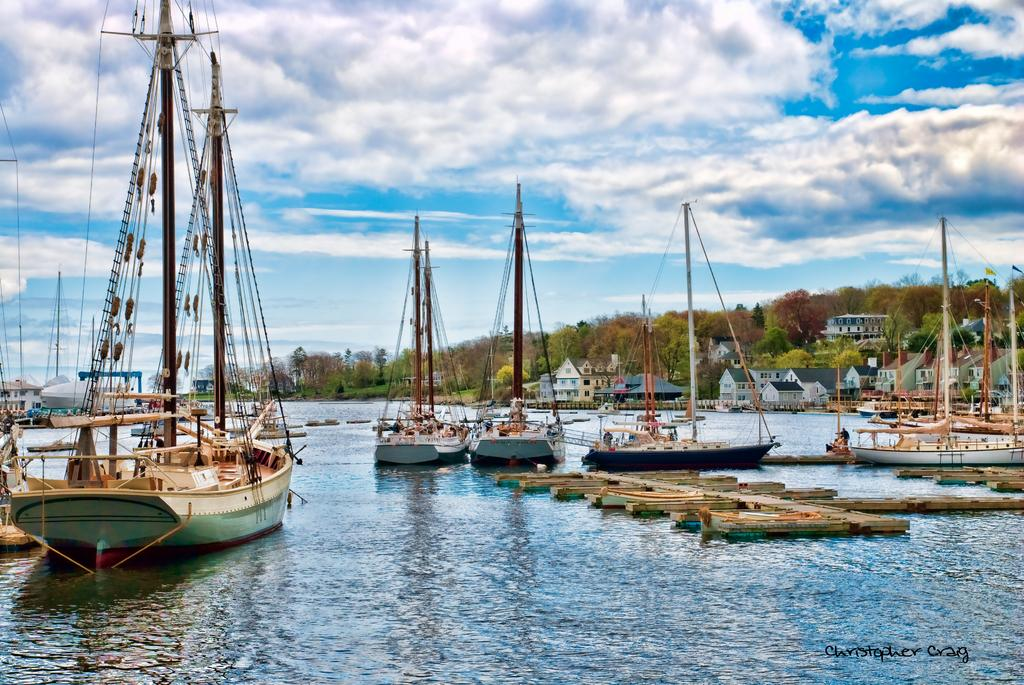What is in the water in the image? There are boats in the water in the image. What can be seen in the background of the image? There are houses and trees with green color in the background. What is the color of the sky in the image? The sky is blue and white in color. What type of lipstick is the son wearing in the image? There is no son or lipstick present in the image; it features boats in the water, houses, trees, and a blue and white sky. 